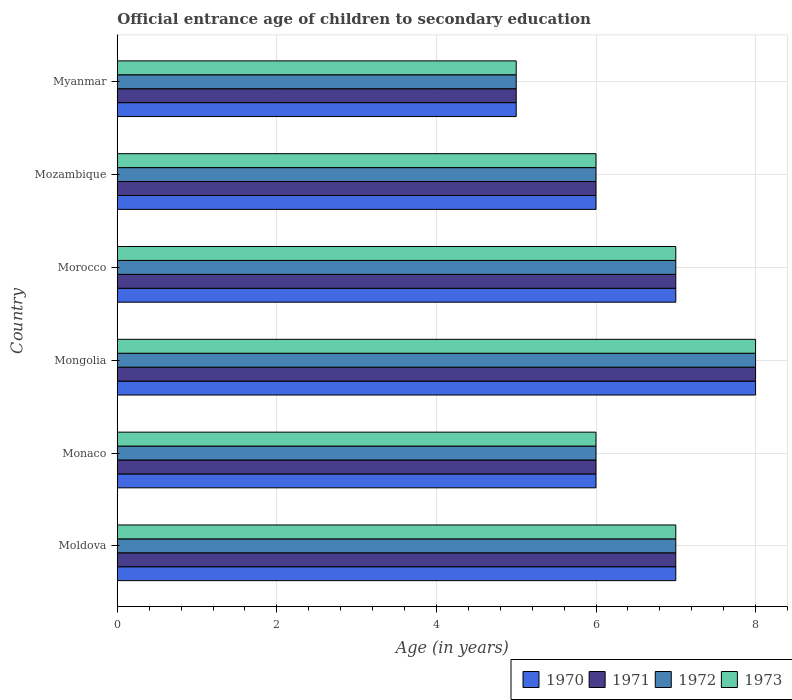How many groups of bars are there?
Your answer should be very brief. 6. Are the number of bars per tick equal to the number of legend labels?
Your answer should be very brief. Yes. Are the number of bars on each tick of the Y-axis equal?
Provide a short and direct response. Yes. What is the label of the 3rd group of bars from the top?
Provide a succinct answer. Morocco. What is the secondary school starting age of children in 1970 in Myanmar?
Keep it short and to the point. 5. Across all countries, what is the minimum secondary school starting age of children in 1971?
Provide a short and direct response. 5. In which country was the secondary school starting age of children in 1971 maximum?
Give a very brief answer. Mongolia. In which country was the secondary school starting age of children in 1970 minimum?
Keep it short and to the point. Myanmar. What is the difference between the secondary school starting age of children in 1970 in Morocco and that in Mozambique?
Provide a short and direct response. 1. What is the difference between the secondary school starting age of children in 1971 in Morocco and the secondary school starting age of children in 1972 in Mongolia?
Your answer should be compact. -1. What is the average secondary school starting age of children in 1971 per country?
Make the answer very short. 6.5. What is the difference between the secondary school starting age of children in 1970 and secondary school starting age of children in 1971 in Monaco?
Your answer should be very brief. 0. In how many countries, is the secondary school starting age of children in 1972 greater than 6.4 years?
Offer a very short reply. 3. What is the ratio of the secondary school starting age of children in 1972 in Morocco to that in Myanmar?
Your answer should be very brief. 1.4. Is the difference between the secondary school starting age of children in 1970 in Moldova and Morocco greater than the difference between the secondary school starting age of children in 1971 in Moldova and Morocco?
Offer a terse response. No. What is the difference between the highest and the second highest secondary school starting age of children in 1973?
Your response must be concise. 1. In how many countries, is the secondary school starting age of children in 1972 greater than the average secondary school starting age of children in 1972 taken over all countries?
Your answer should be compact. 3. Is the sum of the secondary school starting age of children in 1971 in Mozambique and Myanmar greater than the maximum secondary school starting age of children in 1972 across all countries?
Give a very brief answer. Yes. What does the 4th bar from the top in Moldova represents?
Your answer should be very brief. 1970. Are all the bars in the graph horizontal?
Keep it short and to the point. Yes. What is the difference between two consecutive major ticks on the X-axis?
Make the answer very short. 2. Are the values on the major ticks of X-axis written in scientific E-notation?
Your answer should be very brief. No. Does the graph contain any zero values?
Provide a succinct answer. No. Does the graph contain grids?
Keep it short and to the point. Yes. How are the legend labels stacked?
Provide a succinct answer. Horizontal. What is the title of the graph?
Keep it short and to the point. Official entrance age of children to secondary education. What is the label or title of the X-axis?
Offer a terse response. Age (in years). What is the Age (in years) in 1973 in Moldova?
Ensure brevity in your answer.  7. What is the Age (in years) in 1970 in Monaco?
Offer a terse response. 6. What is the Age (in years) of 1970 in Mongolia?
Make the answer very short. 8. What is the Age (in years) in 1971 in Mongolia?
Your answer should be very brief. 8. What is the Age (in years) of 1972 in Mongolia?
Your response must be concise. 8. What is the Age (in years) in 1973 in Mongolia?
Offer a terse response. 8. What is the Age (in years) in 1970 in Morocco?
Your response must be concise. 7. What is the Age (in years) of 1971 in Morocco?
Offer a very short reply. 7. What is the Age (in years) of 1972 in Morocco?
Your answer should be compact. 7. What is the Age (in years) of 1973 in Morocco?
Provide a short and direct response. 7. What is the Age (in years) in 1973 in Mozambique?
Make the answer very short. 6. What is the Age (in years) in 1970 in Myanmar?
Your response must be concise. 5. What is the Age (in years) in 1971 in Myanmar?
Your answer should be compact. 5. What is the Age (in years) in 1972 in Myanmar?
Give a very brief answer. 5. What is the Age (in years) in 1973 in Myanmar?
Offer a terse response. 5. Across all countries, what is the maximum Age (in years) in 1970?
Offer a terse response. 8. Across all countries, what is the maximum Age (in years) of 1971?
Keep it short and to the point. 8. Across all countries, what is the minimum Age (in years) of 1973?
Provide a succinct answer. 5. What is the total Age (in years) in 1970 in the graph?
Keep it short and to the point. 39. What is the total Age (in years) of 1971 in the graph?
Make the answer very short. 39. What is the total Age (in years) in 1972 in the graph?
Keep it short and to the point. 39. What is the difference between the Age (in years) of 1970 in Moldova and that in Monaco?
Offer a very short reply. 1. What is the difference between the Age (in years) of 1971 in Moldova and that in Monaco?
Offer a terse response. 1. What is the difference between the Age (in years) of 1972 in Moldova and that in Monaco?
Keep it short and to the point. 1. What is the difference between the Age (in years) in 1971 in Moldova and that in Morocco?
Provide a succinct answer. 0. What is the difference between the Age (in years) in 1972 in Moldova and that in Morocco?
Keep it short and to the point. 0. What is the difference between the Age (in years) of 1973 in Moldova and that in Morocco?
Ensure brevity in your answer.  0. What is the difference between the Age (in years) in 1972 in Moldova and that in Mozambique?
Your answer should be compact. 1. What is the difference between the Age (in years) in 1973 in Moldova and that in Mozambique?
Your answer should be compact. 1. What is the difference between the Age (in years) of 1972 in Moldova and that in Myanmar?
Your answer should be compact. 2. What is the difference between the Age (in years) of 1973 in Moldova and that in Myanmar?
Provide a succinct answer. 2. What is the difference between the Age (in years) in 1971 in Monaco and that in Mongolia?
Your response must be concise. -2. What is the difference between the Age (in years) of 1972 in Monaco and that in Mongolia?
Your answer should be very brief. -2. What is the difference between the Age (in years) of 1970 in Monaco and that in Morocco?
Your answer should be very brief. -1. What is the difference between the Age (in years) in 1972 in Monaco and that in Morocco?
Provide a short and direct response. -1. What is the difference between the Age (in years) in 1973 in Monaco and that in Morocco?
Offer a terse response. -1. What is the difference between the Age (in years) in 1970 in Monaco and that in Mozambique?
Ensure brevity in your answer.  0. What is the difference between the Age (in years) in 1971 in Monaco and that in Mozambique?
Give a very brief answer. 0. What is the difference between the Age (in years) in 1972 in Monaco and that in Mozambique?
Your response must be concise. 0. What is the difference between the Age (in years) of 1973 in Monaco and that in Mozambique?
Your response must be concise. 0. What is the difference between the Age (in years) of 1971 in Monaco and that in Myanmar?
Offer a terse response. 1. What is the difference between the Age (in years) of 1972 in Monaco and that in Myanmar?
Ensure brevity in your answer.  1. What is the difference between the Age (in years) in 1970 in Mongolia and that in Morocco?
Make the answer very short. 1. What is the difference between the Age (in years) of 1972 in Mongolia and that in Morocco?
Ensure brevity in your answer.  1. What is the difference between the Age (in years) of 1973 in Mongolia and that in Morocco?
Offer a terse response. 1. What is the difference between the Age (in years) in 1970 in Mongolia and that in Mozambique?
Provide a succinct answer. 2. What is the difference between the Age (in years) of 1972 in Mongolia and that in Mozambique?
Offer a very short reply. 2. What is the difference between the Age (in years) of 1970 in Mongolia and that in Myanmar?
Provide a succinct answer. 3. What is the difference between the Age (in years) of 1971 in Mongolia and that in Myanmar?
Give a very brief answer. 3. What is the difference between the Age (in years) of 1972 in Mongolia and that in Myanmar?
Ensure brevity in your answer.  3. What is the difference between the Age (in years) in 1972 in Morocco and that in Mozambique?
Provide a short and direct response. 1. What is the difference between the Age (in years) in 1971 in Morocco and that in Myanmar?
Offer a very short reply. 2. What is the difference between the Age (in years) of 1971 in Mozambique and that in Myanmar?
Keep it short and to the point. 1. What is the difference between the Age (in years) of 1973 in Mozambique and that in Myanmar?
Offer a very short reply. 1. What is the difference between the Age (in years) in 1970 in Moldova and the Age (in years) in 1971 in Monaco?
Your response must be concise. 1. What is the difference between the Age (in years) of 1972 in Moldova and the Age (in years) of 1973 in Monaco?
Your answer should be very brief. 1. What is the difference between the Age (in years) in 1970 in Moldova and the Age (in years) in 1971 in Mongolia?
Provide a succinct answer. -1. What is the difference between the Age (in years) of 1970 in Moldova and the Age (in years) of 1972 in Mongolia?
Your response must be concise. -1. What is the difference between the Age (in years) in 1971 in Moldova and the Age (in years) in 1972 in Mongolia?
Provide a short and direct response. -1. What is the difference between the Age (in years) of 1971 in Moldova and the Age (in years) of 1973 in Mongolia?
Offer a terse response. -1. What is the difference between the Age (in years) in 1970 in Moldova and the Age (in years) in 1971 in Morocco?
Make the answer very short. 0. What is the difference between the Age (in years) in 1970 in Moldova and the Age (in years) in 1972 in Morocco?
Provide a succinct answer. 0. What is the difference between the Age (in years) in 1971 in Moldova and the Age (in years) in 1972 in Morocco?
Give a very brief answer. 0. What is the difference between the Age (in years) of 1971 in Moldova and the Age (in years) of 1973 in Morocco?
Offer a very short reply. 0. What is the difference between the Age (in years) of 1971 in Moldova and the Age (in years) of 1972 in Mozambique?
Provide a short and direct response. 1. What is the difference between the Age (in years) in 1971 in Moldova and the Age (in years) in 1973 in Mozambique?
Keep it short and to the point. 1. What is the difference between the Age (in years) in 1970 in Moldova and the Age (in years) in 1971 in Myanmar?
Make the answer very short. 2. What is the difference between the Age (in years) in 1970 in Moldova and the Age (in years) in 1972 in Myanmar?
Give a very brief answer. 2. What is the difference between the Age (in years) in 1970 in Moldova and the Age (in years) in 1973 in Myanmar?
Your answer should be compact. 2. What is the difference between the Age (in years) in 1971 in Moldova and the Age (in years) in 1972 in Myanmar?
Offer a very short reply. 2. What is the difference between the Age (in years) in 1970 in Monaco and the Age (in years) in 1972 in Mongolia?
Offer a very short reply. -2. What is the difference between the Age (in years) of 1970 in Monaco and the Age (in years) of 1973 in Mongolia?
Offer a terse response. -2. What is the difference between the Age (in years) of 1971 in Monaco and the Age (in years) of 1972 in Mongolia?
Keep it short and to the point. -2. What is the difference between the Age (in years) in 1972 in Monaco and the Age (in years) in 1973 in Mongolia?
Provide a succinct answer. -2. What is the difference between the Age (in years) in 1971 in Monaco and the Age (in years) in 1973 in Morocco?
Provide a succinct answer. -1. What is the difference between the Age (in years) of 1970 in Monaco and the Age (in years) of 1971 in Mozambique?
Offer a terse response. 0. What is the difference between the Age (in years) of 1970 in Monaco and the Age (in years) of 1972 in Mozambique?
Your answer should be compact. 0. What is the difference between the Age (in years) of 1971 in Monaco and the Age (in years) of 1972 in Mozambique?
Provide a short and direct response. 0. What is the difference between the Age (in years) in 1972 in Monaco and the Age (in years) in 1973 in Mozambique?
Your response must be concise. 0. What is the difference between the Age (in years) in 1970 in Monaco and the Age (in years) in 1971 in Myanmar?
Ensure brevity in your answer.  1. What is the difference between the Age (in years) of 1970 in Monaco and the Age (in years) of 1972 in Myanmar?
Provide a succinct answer. 1. What is the difference between the Age (in years) in 1970 in Mongolia and the Age (in years) in 1972 in Morocco?
Give a very brief answer. 1. What is the difference between the Age (in years) of 1970 in Mongolia and the Age (in years) of 1973 in Morocco?
Give a very brief answer. 1. What is the difference between the Age (in years) of 1971 in Mongolia and the Age (in years) of 1973 in Morocco?
Your answer should be compact. 1. What is the difference between the Age (in years) in 1972 in Mongolia and the Age (in years) in 1973 in Morocco?
Ensure brevity in your answer.  1. What is the difference between the Age (in years) of 1970 in Mongolia and the Age (in years) of 1971 in Mozambique?
Offer a terse response. 2. What is the difference between the Age (in years) in 1971 in Mongolia and the Age (in years) in 1972 in Mozambique?
Provide a short and direct response. 2. What is the difference between the Age (in years) in 1972 in Mongolia and the Age (in years) in 1973 in Mozambique?
Your response must be concise. 2. What is the difference between the Age (in years) of 1970 in Mongolia and the Age (in years) of 1972 in Myanmar?
Provide a short and direct response. 3. What is the difference between the Age (in years) in 1971 in Mongolia and the Age (in years) in 1973 in Myanmar?
Provide a short and direct response. 3. What is the difference between the Age (in years) of 1970 in Morocco and the Age (in years) of 1973 in Mozambique?
Make the answer very short. 1. What is the difference between the Age (in years) in 1971 in Morocco and the Age (in years) in 1973 in Mozambique?
Provide a short and direct response. 1. What is the difference between the Age (in years) of 1972 in Morocco and the Age (in years) of 1973 in Mozambique?
Offer a terse response. 1. What is the difference between the Age (in years) in 1970 in Morocco and the Age (in years) in 1972 in Myanmar?
Ensure brevity in your answer.  2. What is the difference between the Age (in years) in 1971 in Morocco and the Age (in years) in 1972 in Myanmar?
Your answer should be very brief. 2. What is the difference between the Age (in years) of 1972 in Morocco and the Age (in years) of 1973 in Myanmar?
Provide a succinct answer. 2. What is the difference between the Age (in years) in 1970 in Mozambique and the Age (in years) in 1973 in Myanmar?
Offer a terse response. 1. What is the difference between the Age (in years) in 1971 in Mozambique and the Age (in years) in 1973 in Myanmar?
Offer a terse response. 1. What is the average Age (in years) of 1970 per country?
Your response must be concise. 6.5. What is the average Age (in years) in 1973 per country?
Your response must be concise. 6.5. What is the difference between the Age (in years) in 1970 and Age (in years) in 1972 in Moldova?
Your answer should be compact. 0. What is the difference between the Age (in years) of 1971 and Age (in years) of 1973 in Moldova?
Give a very brief answer. 0. What is the difference between the Age (in years) in 1970 and Age (in years) in 1971 in Monaco?
Keep it short and to the point. 0. What is the difference between the Age (in years) of 1970 and Age (in years) of 1972 in Monaco?
Provide a short and direct response. 0. What is the difference between the Age (in years) in 1971 and Age (in years) in 1972 in Monaco?
Ensure brevity in your answer.  0. What is the difference between the Age (in years) of 1971 and Age (in years) of 1973 in Monaco?
Offer a terse response. 0. What is the difference between the Age (in years) of 1971 and Age (in years) of 1973 in Mongolia?
Make the answer very short. 0. What is the difference between the Age (in years) of 1972 and Age (in years) of 1973 in Mongolia?
Ensure brevity in your answer.  0. What is the difference between the Age (in years) in 1970 and Age (in years) in 1972 in Morocco?
Give a very brief answer. 0. What is the difference between the Age (in years) of 1970 and Age (in years) of 1973 in Morocco?
Make the answer very short. 0. What is the difference between the Age (in years) in 1970 and Age (in years) in 1973 in Mozambique?
Your answer should be very brief. 0. What is the difference between the Age (in years) of 1971 and Age (in years) of 1972 in Mozambique?
Make the answer very short. 0. What is the difference between the Age (in years) of 1971 and Age (in years) of 1973 in Mozambique?
Make the answer very short. 0. What is the difference between the Age (in years) in 1972 and Age (in years) in 1973 in Mozambique?
Your answer should be very brief. 0. What is the difference between the Age (in years) of 1970 and Age (in years) of 1972 in Myanmar?
Offer a very short reply. 0. What is the ratio of the Age (in years) in 1970 in Moldova to that in Monaco?
Keep it short and to the point. 1.17. What is the ratio of the Age (in years) in 1971 in Moldova to that in Monaco?
Offer a terse response. 1.17. What is the ratio of the Age (in years) of 1972 in Moldova to that in Monaco?
Offer a very short reply. 1.17. What is the ratio of the Age (in years) in 1973 in Moldova to that in Monaco?
Give a very brief answer. 1.17. What is the ratio of the Age (in years) in 1970 in Moldova to that in Mongolia?
Your response must be concise. 0.88. What is the ratio of the Age (in years) in 1972 in Moldova to that in Morocco?
Offer a terse response. 1. What is the ratio of the Age (in years) of 1973 in Moldova to that in Morocco?
Your answer should be compact. 1. What is the ratio of the Age (in years) of 1970 in Moldova to that in Mozambique?
Offer a very short reply. 1.17. What is the ratio of the Age (in years) in 1971 in Moldova to that in Mozambique?
Ensure brevity in your answer.  1.17. What is the ratio of the Age (in years) in 1970 in Moldova to that in Myanmar?
Make the answer very short. 1.4. What is the ratio of the Age (in years) of 1971 in Monaco to that in Morocco?
Make the answer very short. 0.86. What is the ratio of the Age (in years) in 1970 in Monaco to that in Mozambique?
Offer a terse response. 1. What is the ratio of the Age (in years) of 1972 in Monaco to that in Myanmar?
Keep it short and to the point. 1.2. What is the ratio of the Age (in years) in 1973 in Monaco to that in Myanmar?
Ensure brevity in your answer.  1.2. What is the ratio of the Age (in years) of 1973 in Mongolia to that in Morocco?
Your answer should be very brief. 1.14. What is the ratio of the Age (in years) in 1970 in Mongolia to that in Mozambique?
Offer a terse response. 1.33. What is the ratio of the Age (in years) in 1971 in Mongolia to that in Mozambique?
Your response must be concise. 1.33. What is the ratio of the Age (in years) of 1970 in Mongolia to that in Myanmar?
Your response must be concise. 1.6. What is the ratio of the Age (in years) of 1972 in Mongolia to that in Myanmar?
Make the answer very short. 1.6. What is the ratio of the Age (in years) in 1973 in Mongolia to that in Myanmar?
Your answer should be very brief. 1.6. What is the ratio of the Age (in years) in 1970 in Morocco to that in Mozambique?
Make the answer very short. 1.17. What is the ratio of the Age (in years) in 1971 in Morocco to that in Mozambique?
Offer a very short reply. 1.17. What is the ratio of the Age (in years) in 1972 in Morocco to that in Mozambique?
Ensure brevity in your answer.  1.17. What is the ratio of the Age (in years) of 1970 in Morocco to that in Myanmar?
Provide a short and direct response. 1.4. What is the ratio of the Age (in years) in 1972 in Morocco to that in Myanmar?
Your answer should be compact. 1.4. What is the ratio of the Age (in years) of 1970 in Mozambique to that in Myanmar?
Offer a terse response. 1.2. What is the ratio of the Age (in years) of 1972 in Mozambique to that in Myanmar?
Keep it short and to the point. 1.2. What is the difference between the highest and the second highest Age (in years) in 1970?
Give a very brief answer. 1. What is the difference between the highest and the second highest Age (in years) of 1971?
Make the answer very short. 1. What is the difference between the highest and the second highest Age (in years) of 1972?
Offer a terse response. 1. What is the difference between the highest and the second highest Age (in years) in 1973?
Keep it short and to the point. 1. What is the difference between the highest and the lowest Age (in years) in 1970?
Your answer should be compact. 3. What is the difference between the highest and the lowest Age (in years) of 1971?
Give a very brief answer. 3. What is the difference between the highest and the lowest Age (in years) of 1972?
Keep it short and to the point. 3. 